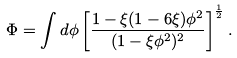<formula> <loc_0><loc_0><loc_500><loc_500>\Phi = \int d \phi \left [ \frac { 1 - \xi ( 1 - 6 \xi ) \phi ^ { 2 } } { ( 1 - \xi \phi ^ { 2 } ) ^ { 2 } } \right ] ^ { \frac { 1 } { 2 } } .</formula> 